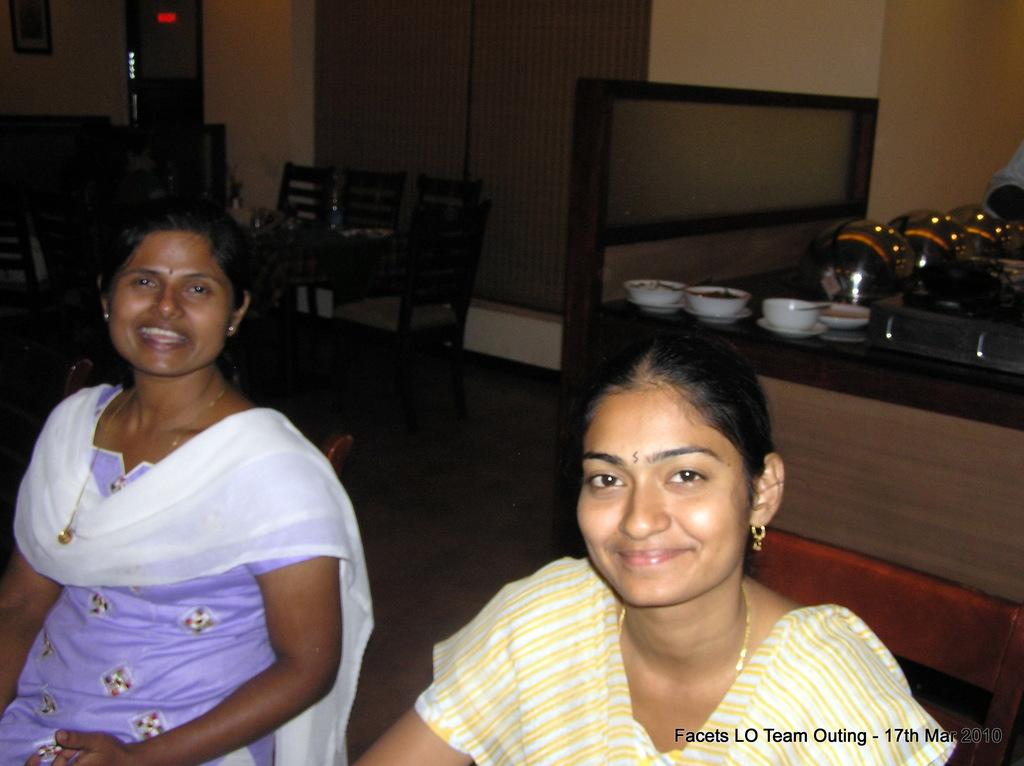How many people are in the image? There are two women in the image. What are the women doing in the image? The women are sitting and smiling. What type of furniture is present in the image? There is a dining table in the image. What other feature can be seen in the image? There is a kitchen counter in the image. What type of horses are depicted on the kitchen counter in the image? There are no horses present on the kitchen counter or anywhere else in the image. What belief system do the women in the image follow? There is no information about the women's beliefs in the image. 